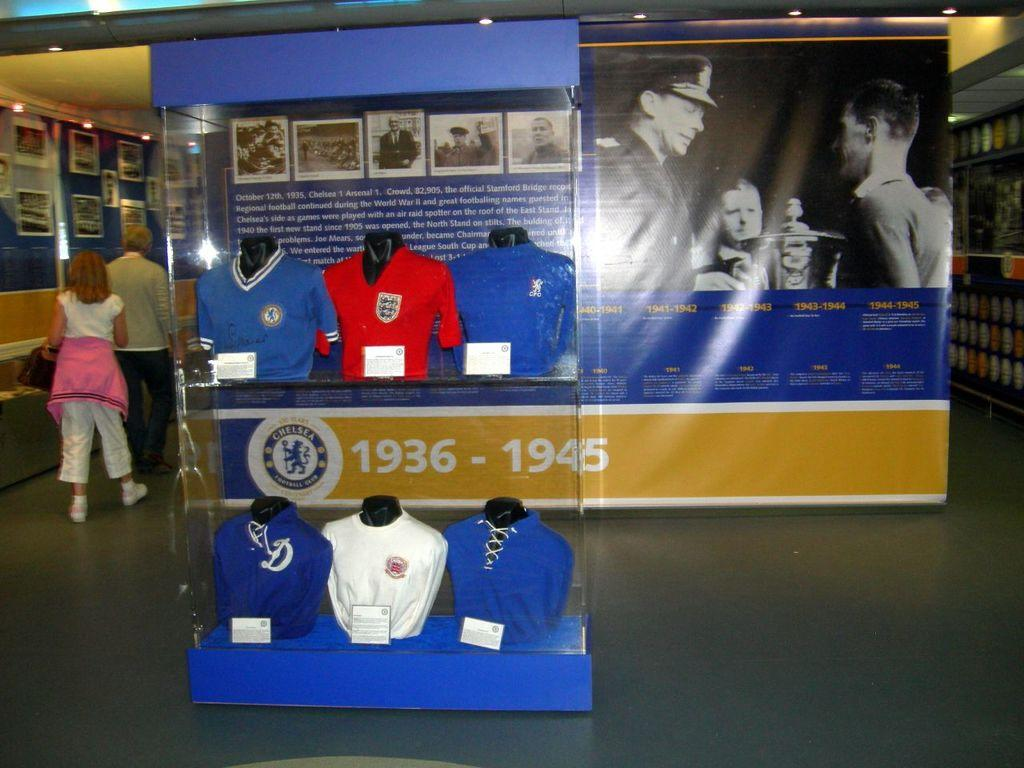<image>
Present a compact description of the photo's key features. the inside of a building with a picture on the wall labeled '1936-1945' at the bottom 